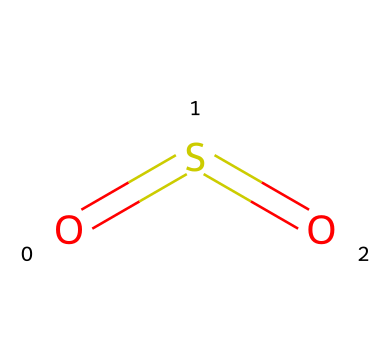What is the molecular formula of the compound? The chemical structure represents sulfur dioxide, which consists of one sulfur atom and two oxygen atoms. Therefore, the molecular formula can be deduced as SO2.
Answer: SO2 How many bonds are present in sulfur dioxide? In the SMILES representation, each '=' indicates a double bond. There are two double bonds in the structure connecting sulfur and oxygen, resulting in a total of two bonds.
Answer: 2 What type of oxidation state does sulfur have in this compound? To find the oxidation state of sulfur in sulfur dioxide (SO2), recognize that oxygen typically has an oxidation state of -2. In total, with two oxygens, the sum is -4. Therefore, sulfur must have an oxidation state of +4 to balance the overall charge to zero.
Answer: +4 What is the molecular geometry around the sulfur atom? The arrangement of the bonds in sulfur dioxide is described by its electron-pair geometry. Sulfur is at the center with two double bonds to oxygen atoms, which dictates a bent molecular shape due to repulsion from lone pairs, leading to an angular (bent) geometry.
Answer: bent What is a significant environmental consequence of sulfur dioxide emissions? Sulfur dioxide can lead to the formation of acid rain when it reacts with water in the atmosphere, causing ecological damage and affecting landscapes and aquatic systems. This understood context helps reveal the environmental importance of its emissions.
Answer: acid rain What kind of chemical reactions is sulfur dioxide commonly involved in? Sulfur dioxide is frequently involved in redox reactions, especially in combustion and the oxidation-reduction of sulfur compounds. Its ability to donate electrons makes it a relevant reactant in these processes.
Answer: redox reactions 